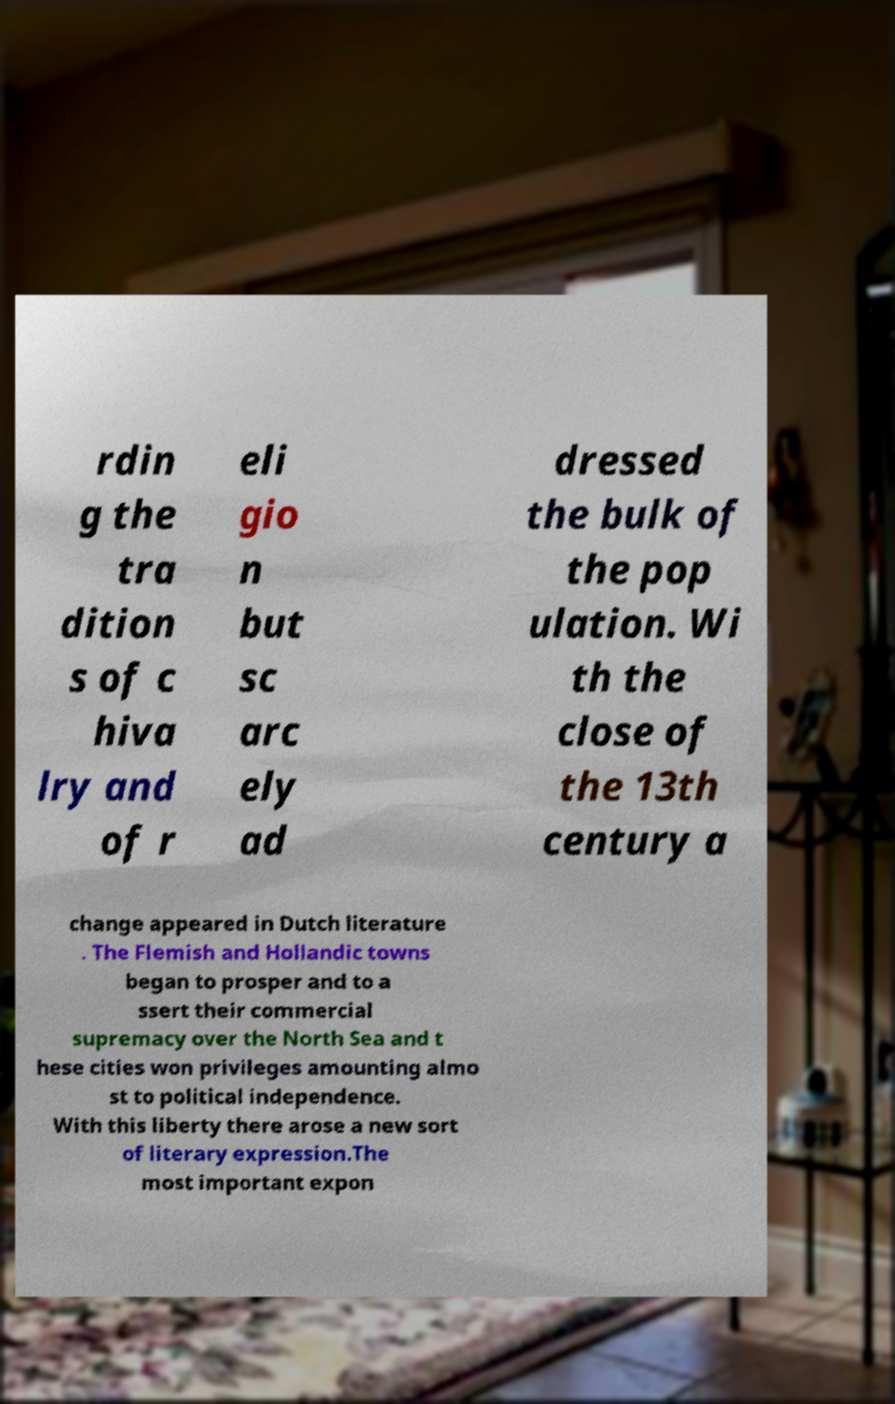I need the written content from this picture converted into text. Can you do that? rdin g the tra dition s of c hiva lry and of r eli gio n but sc arc ely ad dressed the bulk of the pop ulation. Wi th the close of the 13th century a change appeared in Dutch literature . The Flemish and Hollandic towns began to prosper and to a ssert their commercial supremacy over the North Sea and t hese cities won privileges amounting almo st to political independence. With this liberty there arose a new sort of literary expression.The most important expon 